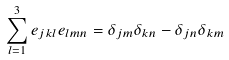<formula> <loc_0><loc_0><loc_500><loc_500>\sum _ { l = 1 } ^ { 3 } e _ { j k l } e _ { l m n } = \delta _ { j m } \delta _ { k n } - \delta _ { j n } \delta _ { k m }</formula> 